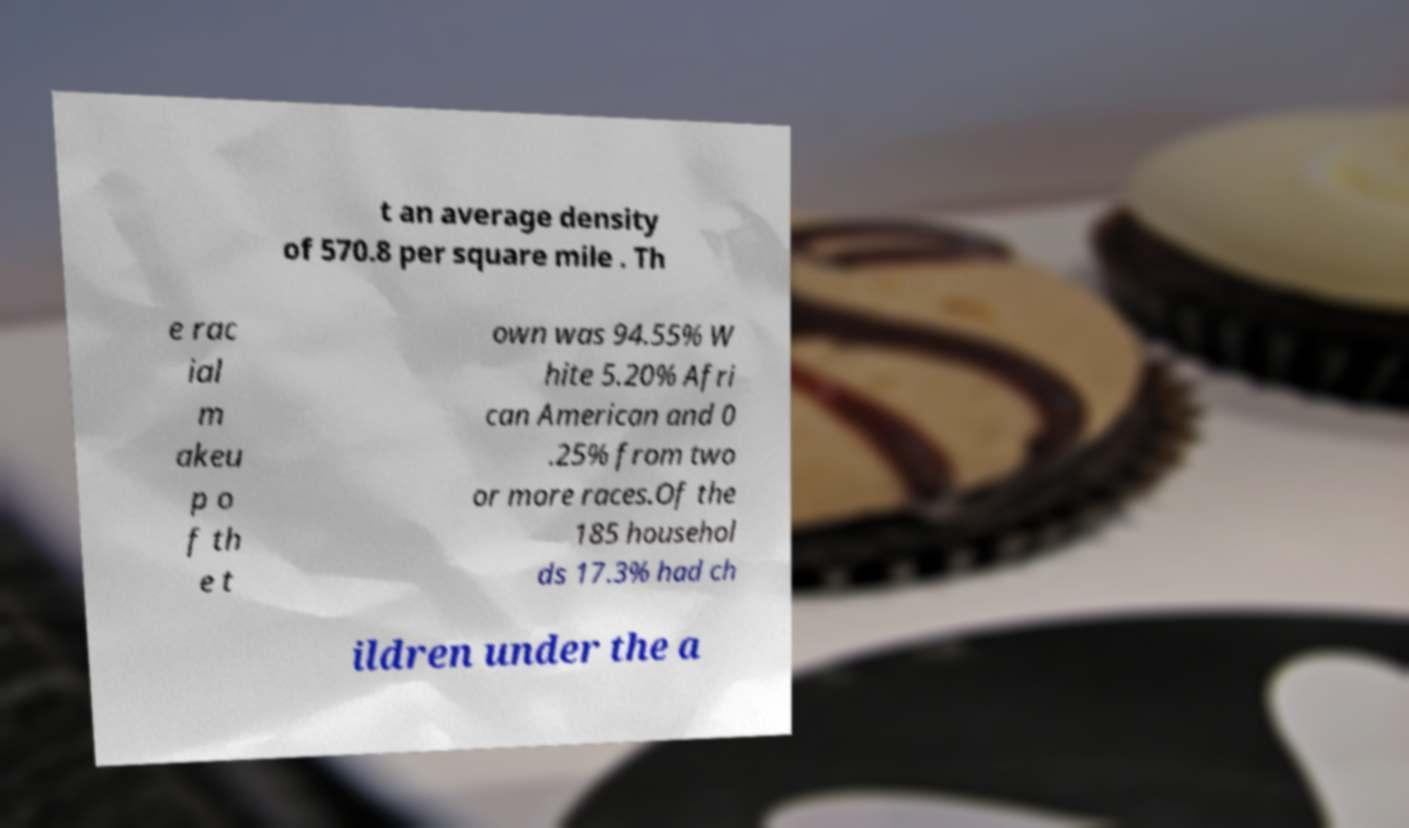Could you extract and type out the text from this image? t an average density of 570.8 per square mile . Th e rac ial m akeu p o f th e t own was 94.55% W hite 5.20% Afri can American and 0 .25% from two or more races.Of the 185 househol ds 17.3% had ch ildren under the a 